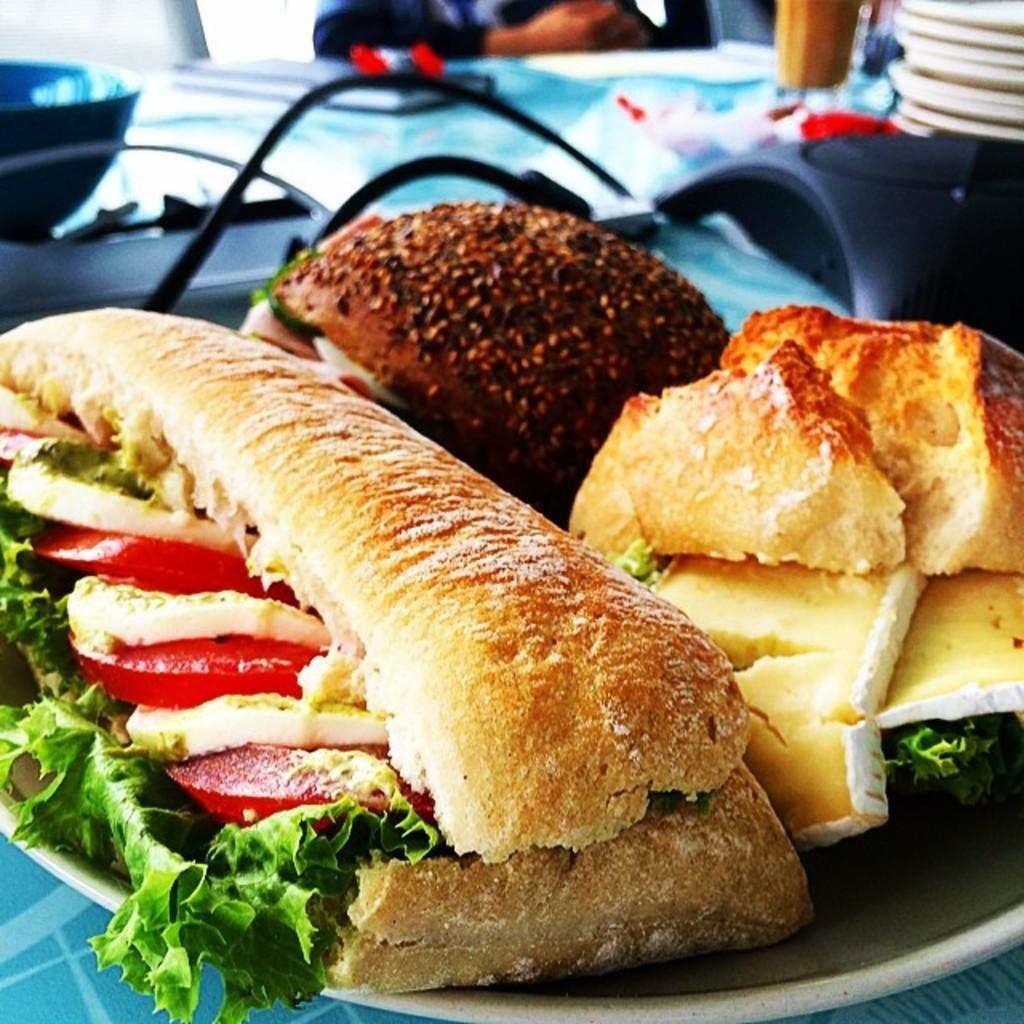What types of food are shown in the image? There are different varieties of burgers in the image. How are the burgers arranged in the image? The burgers are on a plate. What type of fabric is used to make the necktie in the image? There is no necktie present in the image; it only features different varieties of burgers on a plate. 